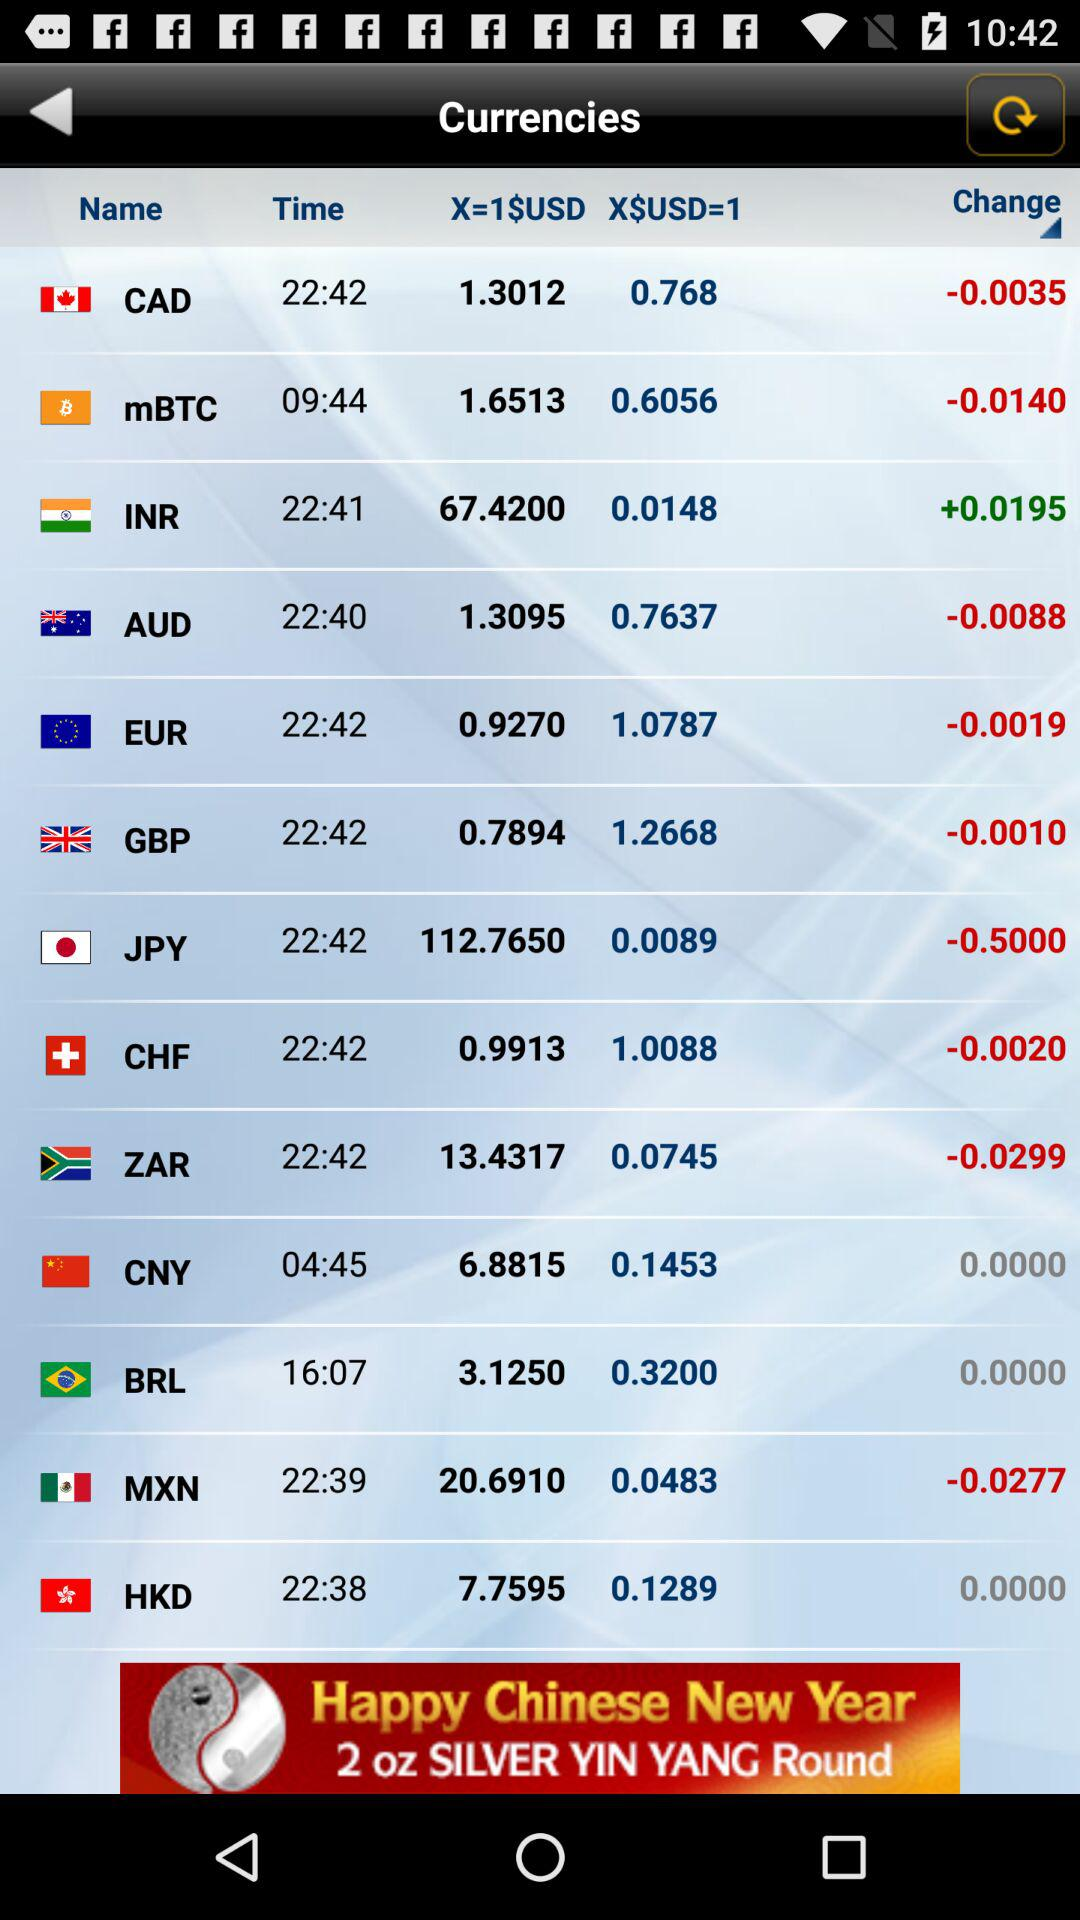How much is 1 USD worth in MXN? The value of 1 USD in MXN is 20.6910. 